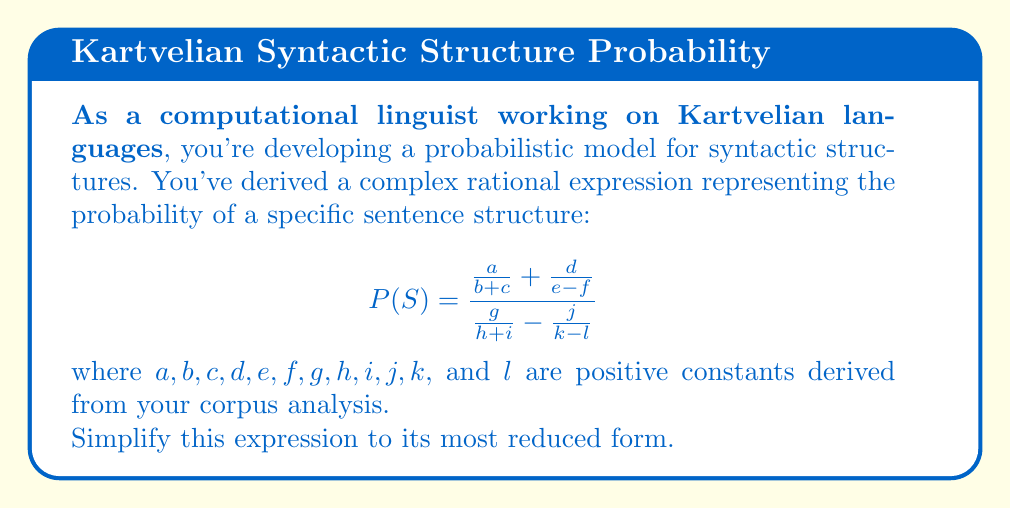Provide a solution to this math problem. Let's simplify this complex rational expression step by step:

1) First, let's find a common denominator for the numerator and denominator separately.

   For the numerator: $(b+c)(e-f)$
   For the denominator: $(h+i)(k-l)$

2) Rewrite the expression:

   $$P(S) = \frac{\frac{a(e-f)}{(b+c)(e-f)} + \frac{d(b+c)}{(b+c)(e-f)}}{\frac{g(k-l)}{(h+i)(k-l)} - \frac{j(h+i)}{(h+i)(k-l)}}$$

3) Simplify the numerator and denominator:

   $$P(S) = \frac{\frac{a(e-f) + d(b+c)}{(b+c)(e-f)}}{\frac{g(k-l) - j(h+i)}{(h+i)(k-l)}}$$

4) Now we have a division of two fractions. To divide fractions, we multiply by the reciprocal:

   $$P(S) = \frac{a(e-f) + d(b+c)}{(b+c)(e-f)} \cdot \frac{(h+i)(k-l)}{g(k-l) - j(h+i)}$$

5) Cancel out common factors if any (in this case, there are none), and we get our final simplified expression:

   $$P(S) = \frac{[a(e-f) + d(b+c)](h+i)(k-l)}{[(b+c)(e-f)][g(k-l) - j(h+i)]}$$

This is the most simplified form of the given complex rational expression.
Answer: $$P(S) = \frac{[a(e-f) + d(b+c)](h+i)(k-l)}{[(b+c)(e-f)][g(k-l) - j(h+i)]}$$ 